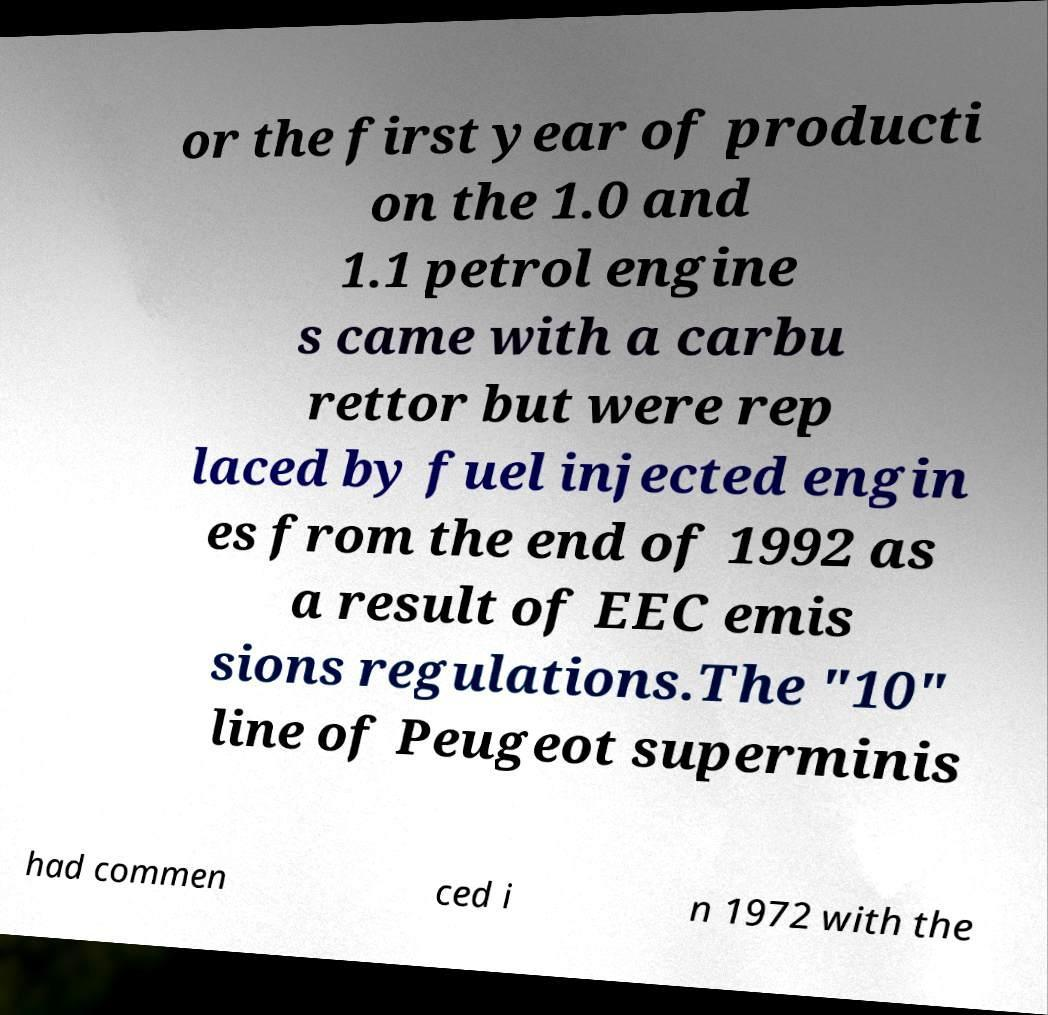What messages or text are displayed in this image? I need them in a readable, typed format. or the first year of producti on the 1.0 and 1.1 petrol engine s came with a carbu rettor but were rep laced by fuel injected engin es from the end of 1992 as a result of EEC emis sions regulations.The "10" line of Peugeot superminis had commen ced i n 1972 with the 